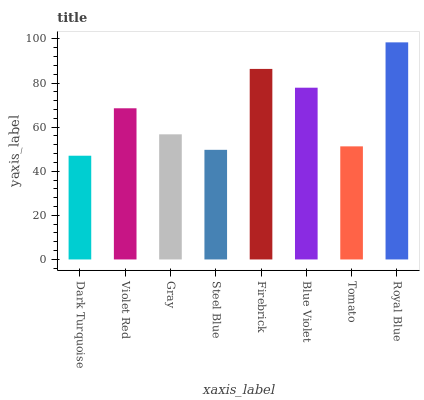Is Violet Red the minimum?
Answer yes or no. No. Is Violet Red the maximum?
Answer yes or no. No. Is Violet Red greater than Dark Turquoise?
Answer yes or no. Yes. Is Dark Turquoise less than Violet Red?
Answer yes or no. Yes. Is Dark Turquoise greater than Violet Red?
Answer yes or no. No. Is Violet Red less than Dark Turquoise?
Answer yes or no. No. Is Violet Red the high median?
Answer yes or no. Yes. Is Gray the low median?
Answer yes or no. Yes. Is Tomato the high median?
Answer yes or no. No. Is Firebrick the low median?
Answer yes or no. No. 